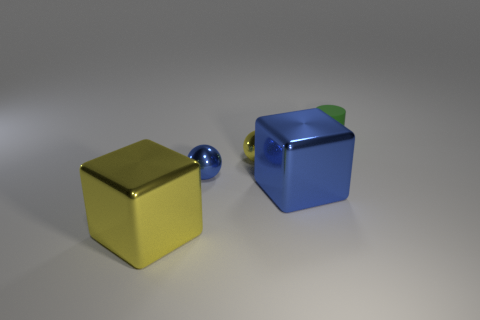Subtract all red cubes. Subtract all cyan spheres. How many cubes are left? 2 Subtract all yellow cylinders. How many gray blocks are left? 0 Subtract all tiny yellow metal spheres. Subtract all green matte objects. How many objects are left? 3 Add 1 tiny yellow metal spheres. How many tiny yellow metal spheres are left? 2 Add 4 red metal objects. How many red metal objects exist? 4 Add 1 small blue things. How many objects exist? 6 Subtract 0 brown cubes. How many objects are left? 5 Subtract all cylinders. How many objects are left? 4 Subtract 1 cubes. How many cubes are left? 1 